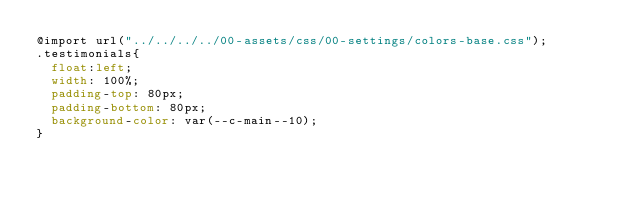<code> <loc_0><loc_0><loc_500><loc_500><_CSS_>@import url("../../../../00-assets/css/00-settings/colors-base.css");
.testimonials{
  float:left;
  width: 100%;
  padding-top: 80px;
  padding-bottom: 80px;
  background-color: var(--c-main--10);
}
</code> 